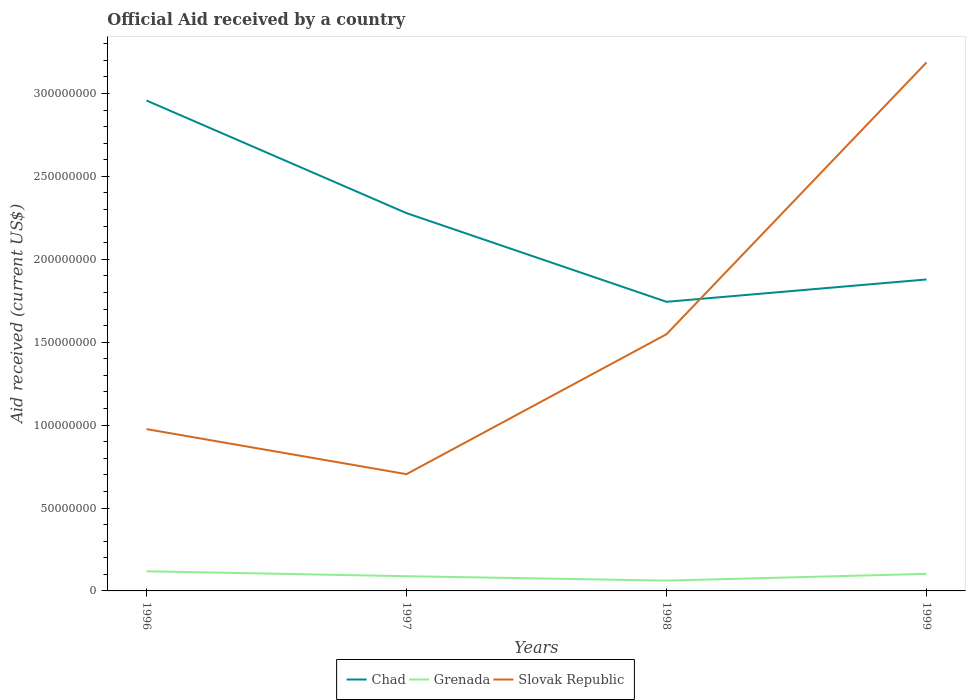How many different coloured lines are there?
Offer a very short reply. 3. Across all years, what is the maximum net official aid received in Chad?
Offer a very short reply. 1.74e+08. What is the total net official aid received in Grenada in the graph?
Offer a very short reply. 2.97e+06. What is the difference between the highest and the second highest net official aid received in Slovak Republic?
Your response must be concise. 2.48e+08. What is the difference between the highest and the lowest net official aid received in Grenada?
Offer a very short reply. 2. How many years are there in the graph?
Ensure brevity in your answer.  4. Does the graph contain any zero values?
Provide a succinct answer. No. What is the title of the graph?
Give a very brief answer. Official Aid received by a country. What is the label or title of the Y-axis?
Provide a short and direct response. Aid received (current US$). What is the Aid received (current US$) in Chad in 1996?
Provide a succinct answer. 2.96e+08. What is the Aid received (current US$) in Grenada in 1996?
Keep it short and to the point. 1.18e+07. What is the Aid received (current US$) of Slovak Republic in 1996?
Make the answer very short. 9.76e+07. What is the Aid received (current US$) of Chad in 1997?
Make the answer very short. 2.28e+08. What is the Aid received (current US$) in Grenada in 1997?
Offer a terse response. 8.88e+06. What is the Aid received (current US$) in Slovak Republic in 1997?
Offer a terse response. 7.04e+07. What is the Aid received (current US$) of Chad in 1998?
Your answer should be compact. 1.74e+08. What is the Aid received (current US$) in Grenada in 1998?
Offer a terse response. 6.22e+06. What is the Aid received (current US$) in Slovak Republic in 1998?
Provide a succinct answer. 1.55e+08. What is the Aid received (current US$) in Chad in 1999?
Give a very brief answer. 1.88e+08. What is the Aid received (current US$) of Grenada in 1999?
Your answer should be very brief. 1.03e+07. What is the Aid received (current US$) of Slovak Republic in 1999?
Make the answer very short. 3.19e+08. Across all years, what is the maximum Aid received (current US$) of Chad?
Offer a terse response. 2.96e+08. Across all years, what is the maximum Aid received (current US$) in Grenada?
Offer a terse response. 1.18e+07. Across all years, what is the maximum Aid received (current US$) of Slovak Republic?
Provide a succinct answer. 3.19e+08. Across all years, what is the minimum Aid received (current US$) in Chad?
Offer a terse response. 1.74e+08. Across all years, what is the minimum Aid received (current US$) of Grenada?
Ensure brevity in your answer.  6.22e+06. Across all years, what is the minimum Aid received (current US$) of Slovak Republic?
Make the answer very short. 7.04e+07. What is the total Aid received (current US$) of Chad in the graph?
Keep it short and to the point. 8.86e+08. What is the total Aid received (current US$) in Grenada in the graph?
Your response must be concise. 3.72e+07. What is the total Aid received (current US$) of Slovak Republic in the graph?
Make the answer very short. 6.42e+08. What is the difference between the Aid received (current US$) of Chad in 1996 and that in 1997?
Your response must be concise. 6.79e+07. What is the difference between the Aid received (current US$) of Grenada in 1996 and that in 1997?
Keep it short and to the point. 2.97e+06. What is the difference between the Aid received (current US$) of Slovak Republic in 1996 and that in 1997?
Make the answer very short. 2.72e+07. What is the difference between the Aid received (current US$) of Chad in 1996 and that in 1998?
Offer a very short reply. 1.21e+08. What is the difference between the Aid received (current US$) in Grenada in 1996 and that in 1998?
Keep it short and to the point. 5.63e+06. What is the difference between the Aid received (current US$) of Slovak Republic in 1996 and that in 1998?
Your answer should be compact. -5.72e+07. What is the difference between the Aid received (current US$) in Chad in 1996 and that in 1999?
Your response must be concise. 1.08e+08. What is the difference between the Aid received (current US$) of Grenada in 1996 and that in 1999?
Provide a succinct answer. 1.56e+06. What is the difference between the Aid received (current US$) in Slovak Republic in 1996 and that in 1999?
Offer a very short reply. -2.21e+08. What is the difference between the Aid received (current US$) of Chad in 1997 and that in 1998?
Ensure brevity in your answer.  5.35e+07. What is the difference between the Aid received (current US$) of Grenada in 1997 and that in 1998?
Keep it short and to the point. 2.66e+06. What is the difference between the Aid received (current US$) of Slovak Republic in 1997 and that in 1998?
Your answer should be very brief. -8.44e+07. What is the difference between the Aid received (current US$) in Chad in 1997 and that in 1999?
Offer a very short reply. 4.00e+07. What is the difference between the Aid received (current US$) of Grenada in 1997 and that in 1999?
Make the answer very short. -1.41e+06. What is the difference between the Aid received (current US$) of Slovak Republic in 1997 and that in 1999?
Give a very brief answer. -2.48e+08. What is the difference between the Aid received (current US$) of Chad in 1998 and that in 1999?
Keep it short and to the point. -1.35e+07. What is the difference between the Aid received (current US$) in Grenada in 1998 and that in 1999?
Offer a very short reply. -4.07e+06. What is the difference between the Aid received (current US$) of Slovak Republic in 1998 and that in 1999?
Your answer should be very brief. -1.64e+08. What is the difference between the Aid received (current US$) in Chad in 1996 and the Aid received (current US$) in Grenada in 1997?
Your answer should be compact. 2.87e+08. What is the difference between the Aid received (current US$) of Chad in 1996 and the Aid received (current US$) of Slovak Republic in 1997?
Your response must be concise. 2.25e+08. What is the difference between the Aid received (current US$) in Grenada in 1996 and the Aid received (current US$) in Slovak Republic in 1997?
Keep it short and to the point. -5.86e+07. What is the difference between the Aid received (current US$) of Chad in 1996 and the Aid received (current US$) of Grenada in 1998?
Give a very brief answer. 2.90e+08. What is the difference between the Aid received (current US$) in Chad in 1996 and the Aid received (current US$) in Slovak Republic in 1998?
Keep it short and to the point. 1.41e+08. What is the difference between the Aid received (current US$) in Grenada in 1996 and the Aid received (current US$) in Slovak Republic in 1998?
Offer a terse response. -1.43e+08. What is the difference between the Aid received (current US$) of Chad in 1996 and the Aid received (current US$) of Grenada in 1999?
Your response must be concise. 2.85e+08. What is the difference between the Aid received (current US$) of Chad in 1996 and the Aid received (current US$) of Slovak Republic in 1999?
Give a very brief answer. -2.29e+07. What is the difference between the Aid received (current US$) of Grenada in 1996 and the Aid received (current US$) of Slovak Republic in 1999?
Provide a succinct answer. -3.07e+08. What is the difference between the Aid received (current US$) of Chad in 1997 and the Aid received (current US$) of Grenada in 1998?
Offer a terse response. 2.22e+08. What is the difference between the Aid received (current US$) in Chad in 1997 and the Aid received (current US$) in Slovak Republic in 1998?
Your answer should be very brief. 7.30e+07. What is the difference between the Aid received (current US$) of Grenada in 1997 and the Aid received (current US$) of Slovak Republic in 1998?
Provide a short and direct response. -1.46e+08. What is the difference between the Aid received (current US$) of Chad in 1997 and the Aid received (current US$) of Grenada in 1999?
Provide a short and direct response. 2.18e+08. What is the difference between the Aid received (current US$) of Chad in 1997 and the Aid received (current US$) of Slovak Republic in 1999?
Give a very brief answer. -9.08e+07. What is the difference between the Aid received (current US$) of Grenada in 1997 and the Aid received (current US$) of Slovak Republic in 1999?
Give a very brief answer. -3.10e+08. What is the difference between the Aid received (current US$) in Chad in 1998 and the Aid received (current US$) in Grenada in 1999?
Your response must be concise. 1.64e+08. What is the difference between the Aid received (current US$) in Chad in 1998 and the Aid received (current US$) in Slovak Republic in 1999?
Keep it short and to the point. -1.44e+08. What is the difference between the Aid received (current US$) in Grenada in 1998 and the Aid received (current US$) in Slovak Republic in 1999?
Offer a very short reply. -3.12e+08. What is the average Aid received (current US$) of Chad per year?
Provide a short and direct response. 2.21e+08. What is the average Aid received (current US$) in Grenada per year?
Your answer should be compact. 9.31e+06. What is the average Aid received (current US$) in Slovak Republic per year?
Give a very brief answer. 1.60e+08. In the year 1996, what is the difference between the Aid received (current US$) in Chad and Aid received (current US$) in Grenada?
Keep it short and to the point. 2.84e+08. In the year 1996, what is the difference between the Aid received (current US$) of Chad and Aid received (current US$) of Slovak Republic?
Provide a short and direct response. 1.98e+08. In the year 1996, what is the difference between the Aid received (current US$) of Grenada and Aid received (current US$) of Slovak Republic?
Keep it short and to the point. -8.57e+07. In the year 1997, what is the difference between the Aid received (current US$) of Chad and Aid received (current US$) of Grenada?
Ensure brevity in your answer.  2.19e+08. In the year 1997, what is the difference between the Aid received (current US$) in Chad and Aid received (current US$) in Slovak Republic?
Give a very brief answer. 1.57e+08. In the year 1997, what is the difference between the Aid received (current US$) in Grenada and Aid received (current US$) in Slovak Republic?
Keep it short and to the point. -6.15e+07. In the year 1998, what is the difference between the Aid received (current US$) of Chad and Aid received (current US$) of Grenada?
Offer a very short reply. 1.68e+08. In the year 1998, what is the difference between the Aid received (current US$) in Chad and Aid received (current US$) in Slovak Republic?
Your response must be concise. 1.96e+07. In the year 1998, what is the difference between the Aid received (current US$) of Grenada and Aid received (current US$) of Slovak Republic?
Your answer should be very brief. -1.49e+08. In the year 1999, what is the difference between the Aid received (current US$) in Chad and Aid received (current US$) in Grenada?
Give a very brief answer. 1.78e+08. In the year 1999, what is the difference between the Aid received (current US$) in Chad and Aid received (current US$) in Slovak Republic?
Keep it short and to the point. -1.31e+08. In the year 1999, what is the difference between the Aid received (current US$) of Grenada and Aid received (current US$) of Slovak Republic?
Your answer should be compact. -3.08e+08. What is the ratio of the Aid received (current US$) of Chad in 1996 to that in 1997?
Make the answer very short. 1.3. What is the ratio of the Aid received (current US$) in Grenada in 1996 to that in 1997?
Ensure brevity in your answer.  1.33. What is the ratio of the Aid received (current US$) of Slovak Republic in 1996 to that in 1997?
Your response must be concise. 1.39. What is the ratio of the Aid received (current US$) of Chad in 1996 to that in 1998?
Provide a short and direct response. 1.7. What is the ratio of the Aid received (current US$) in Grenada in 1996 to that in 1998?
Keep it short and to the point. 1.91. What is the ratio of the Aid received (current US$) in Slovak Republic in 1996 to that in 1998?
Ensure brevity in your answer.  0.63. What is the ratio of the Aid received (current US$) of Chad in 1996 to that in 1999?
Provide a short and direct response. 1.57. What is the ratio of the Aid received (current US$) of Grenada in 1996 to that in 1999?
Make the answer very short. 1.15. What is the ratio of the Aid received (current US$) of Slovak Republic in 1996 to that in 1999?
Your answer should be compact. 0.31. What is the ratio of the Aid received (current US$) in Chad in 1997 to that in 1998?
Your response must be concise. 1.31. What is the ratio of the Aid received (current US$) of Grenada in 1997 to that in 1998?
Your answer should be very brief. 1.43. What is the ratio of the Aid received (current US$) in Slovak Republic in 1997 to that in 1998?
Ensure brevity in your answer.  0.45. What is the ratio of the Aid received (current US$) in Chad in 1997 to that in 1999?
Offer a terse response. 1.21. What is the ratio of the Aid received (current US$) of Grenada in 1997 to that in 1999?
Your response must be concise. 0.86. What is the ratio of the Aid received (current US$) of Slovak Republic in 1997 to that in 1999?
Provide a short and direct response. 0.22. What is the ratio of the Aid received (current US$) of Chad in 1998 to that in 1999?
Provide a short and direct response. 0.93. What is the ratio of the Aid received (current US$) in Grenada in 1998 to that in 1999?
Ensure brevity in your answer.  0.6. What is the ratio of the Aid received (current US$) in Slovak Republic in 1998 to that in 1999?
Make the answer very short. 0.49. What is the difference between the highest and the second highest Aid received (current US$) of Chad?
Provide a short and direct response. 6.79e+07. What is the difference between the highest and the second highest Aid received (current US$) of Grenada?
Your answer should be very brief. 1.56e+06. What is the difference between the highest and the second highest Aid received (current US$) of Slovak Republic?
Provide a short and direct response. 1.64e+08. What is the difference between the highest and the lowest Aid received (current US$) in Chad?
Make the answer very short. 1.21e+08. What is the difference between the highest and the lowest Aid received (current US$) in Grenada?
Ensure brevity in your answer.  5.63e+06. What is the difference between the highest and the lowest Aid received (current US$) in Slovak Republic?
Ensure brevity in your answer.  2.48e+08. 